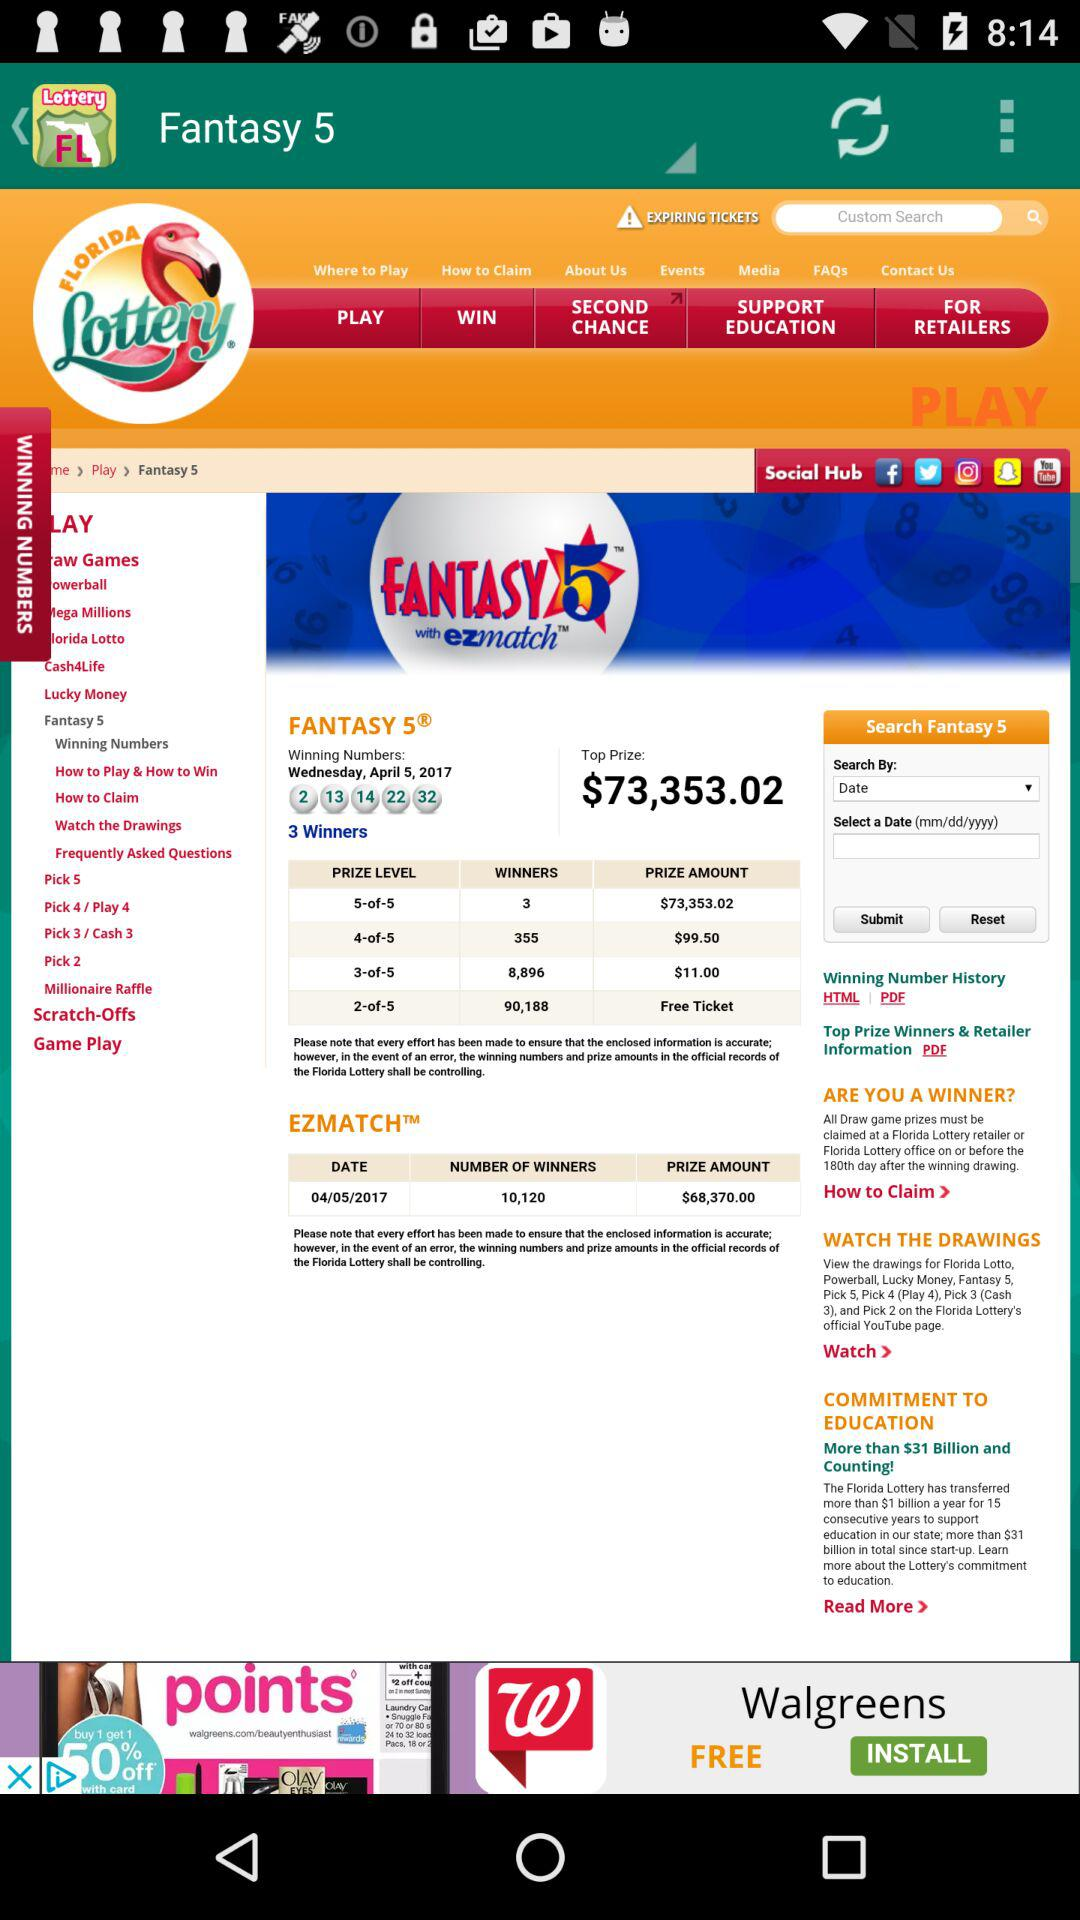What are the different available prize levels? The different available prize levels are 5-of-5, 4-of-5, 3-of-5 and 2-of-5. 